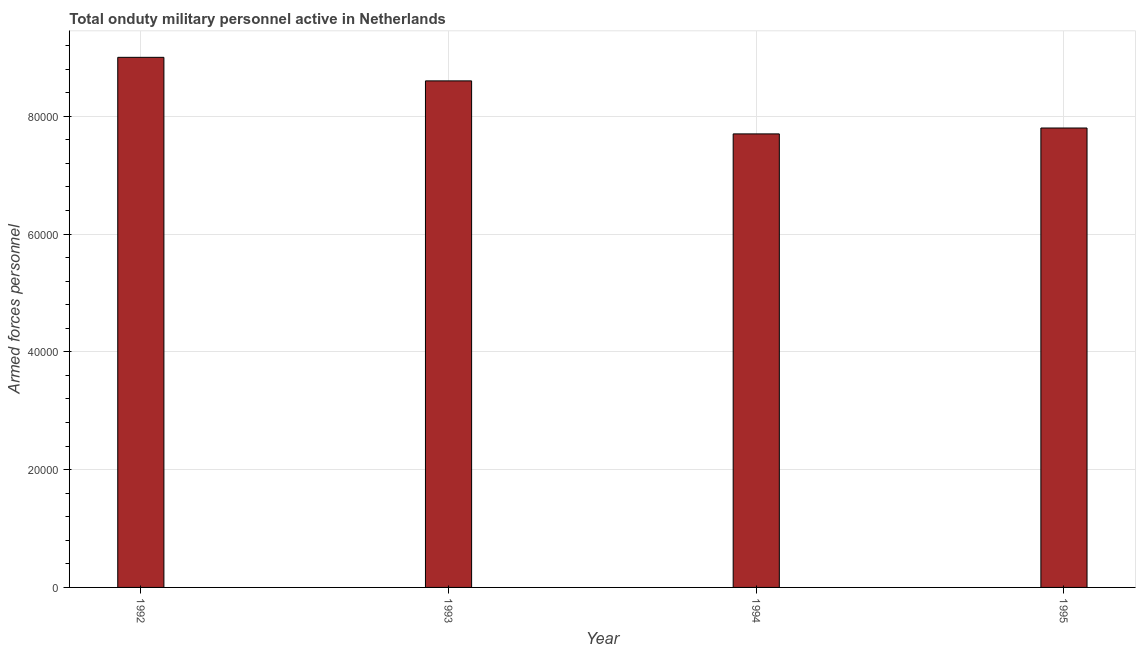Does the graph contain any zero values?
Your answer should be very brief. No. Does the graph contain grids?
Make the answer very short. Yes. What is the title of the graph?
Your answer should be compact. Total onduty military personnel active in Netherlands. What is the label or title of the X-axis?
Provide a short and direct response. Year. What is the label or title of the Y-axis?
Ensure brevity in your answer.  Armed forces personnel. What is the number of armed forces personnel in 1995?
Offer a terse response. 7.80e+04. Across all years, what is the minimum number of armed forces personnel?
Keep it short and to the point. 7.70e+04. In which year was the number of armed forces personnel maximum?
Make the answer very short. 1992. In which year was the number of armed forces personnel minimum?
Give a very brief answer. 1994. What is the sum of the number of armed forces personnel?
Keep it short and to the point. 3.31e+05. What is the difference between the number of armed forces personnel in 1993 and 1995?
Offer a terse response. 8000. What is the average number of armed forces personnel per year?
Keep it short and to the point. 8.28e+04. What is the median number of armed forces personnel?
Keep it short and to the point. 8.20e+04. In how many years, is the number of armed forces personnel greater than 72000 ?
Offer a very short reply. 4. Is the number of armed forces personnel in 1992 less than that in 1995?
Provide a succinct answer. No. Is the difference between the number of armed forces personnel in 1992 and 1993 greater than the difference between any two years?
Offer a very short reply. No. What is the difference between the highest and the second highest number of armed forces personnel?
Provide a succinct answer. 4000. Is the sum of the number of armed forces personnel in 1993 and 1995 greater than the maximum number of armed forces personnel across all years?
Provide a succinct answer. Yes. What is the difference between the highest and the lowest number of armed forces personnel?
Your response must be concise. 1.30e+04. Are all the bars in the graph horizontal?
Provide a succinct answer. No. What is the difference between two consecutive major ticks on the Y-axis?
Provide a succinct answer. 2.00e+04. What is the Armed forces personnel in 1993?
Your answer should be very brief. 8.60e+04. What is the Armed forces personnel in 1994?
Give a very brief answer. 7.70e+04. What is the Armed forces personnel in 1995?
Keep it short and to the point. 7.80e+04. What is the difference between the Armed forces personnel in 1992 and 1993?
Provide a succinct answer. 4000. What is the difference between the Armed forces personnel in 1992 and 1994?
Keep it short and to the point. 1.30e+04. What is the difference between the Armed forces personnel in 1992 and 1995?
Offer a very short reply. 1.20e+04. What is the difference between the Armed forces personnel in 1993 and 1994?
Offer a terse response. 9000. What is the difference between the Armed forces personnel in 1993 and 1995?
Ensure brevity in your answer.  8000. What is the difference between the Armed forces personnel in 1994 and 1995?
Make the answer very short. -1000. What is the ratio of the Armed forces personnel in 1992 to that in 1993?
Give a very brief answer. 1.05. What is the ratio of the Armed forces personnel in 1992 to that in 1994?
Your response must be concise. 1.17. What is the ratio of the Armed forces personnel in 1992 to that in 1995?
Your answer should be very brief. 1.15. What is the ratio of the Armed forces personnel in 1993 to that in 1994?
Provide a succinct answer. 1.12. What is the ratio of the Armed forces personnel in 1993 to that in 1995?
Your response must be concise. 1.1. What is the ratio of the Armed forces personnel in 1994 to that in 1995?
Keep it short and to the point. 0.99. 